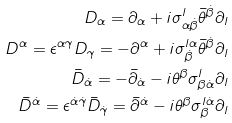<formula> <loc_0><loc_0><loc_500><loc_500>D _ { \alpha } = \partial _ { \alpha } + i \sigma _ { \alpha \dot { \beta } } ^ { l } \bar { \theta } ^ { \dot { \beta } } \partial _ { l } \\ D ^ { \alpha } = \epsilon ^ { \alpha \gamma } D _ { \gamma } = - \partial ^ { \alpha } + i \sigma ^ { l \alpha } _ { \dot { \beta } } \bar { \theta } ^ { \dot { \beta } } \partial _ { l } \\ \bar { D } _ { \dot { \alpha } } = - \bar { \partial } _ { \dot { \alpha } } - i \theta ^ { \beta } \sigma _ { \beta \dot { \alpha } } ^ { l } \partial _ { l } \\ \bar { D } ^ { \dot { \alpha } } = \epsilon ^ { \dot { \alpha } \dot { \gamma } } \bar { D } _ { \dot { \gamma } } = \bar { \partial } ^ { \dot { \alpha } } - i \theta ^ { \beta } \sigma _ { \beta } ^ { l \dot { \alpha } } \partial _ { l }</formula> 